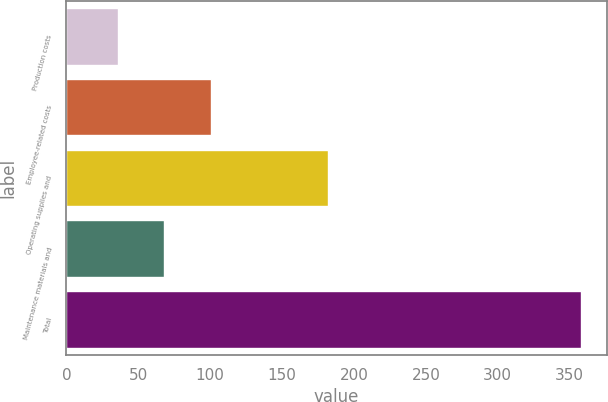Convert chart to OTSL. <chart><loc_0><loc_0><loc_500><loc_500><bar_chart><fcel>Production costs<fcel>Employee-related costs<fcel>Operating supplies and<fcel>Maintenance materials and<fcel>Total<nl><fcel>36<fcel>100.4<fcel>182<fcel>68.2<fcel>358<nl></chart> 